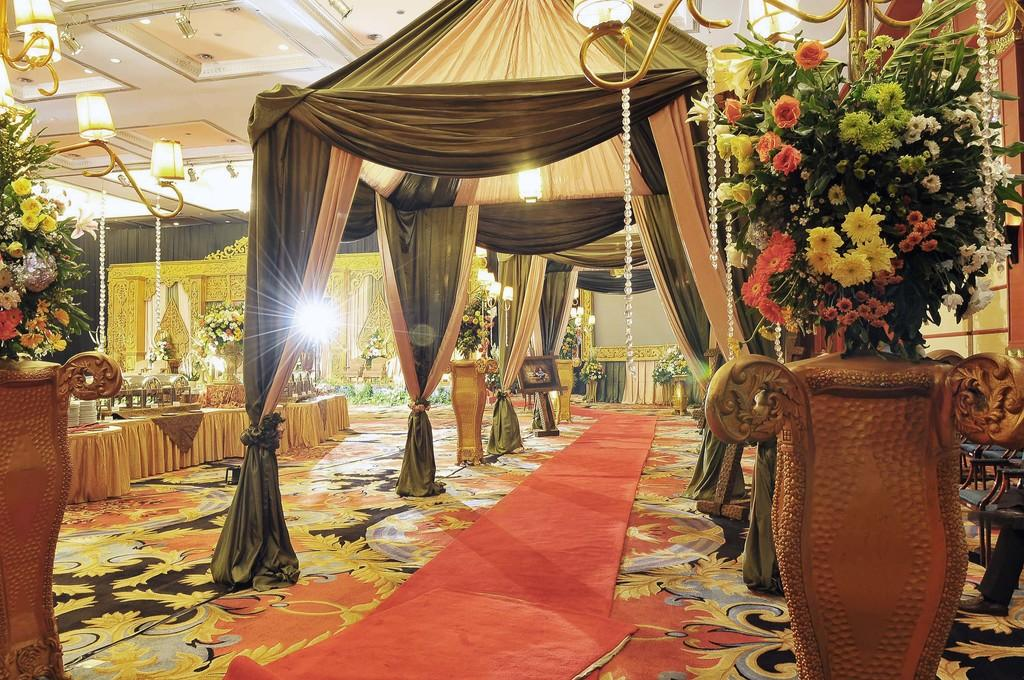What type of space is depicted in the image? The image shows an inner view of a room. What type of window treatment is present in the room? There are curtains in the room. What type of lighting is present in the room? Electric lights and chandeliers are visible in the room. What type of decorative element is present in the room? House plants are in the room. What type of tableware is present in the room? Crockery is present in the room. What type of class is being taught in the room in the image? There is no indication of a class or any teaching activity in the image. How many cakes are visible on the table in the image? There is no mention of cakes in the image; the focus is on the crockery. 